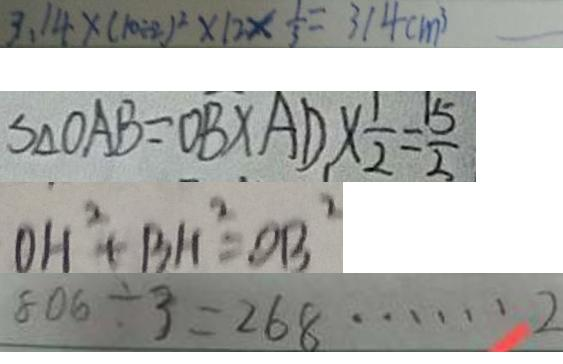Convert formula to latex. <formula><loc_0><loc_0><loc_500><loc_500>3 . 1 4 \times ( 1 0 \div 2 ) ^ { 2 } \times 1 2 \times \frac { 1 } { 3 } = 3 1 4 c m ^ { 3 } 
 S _ { \Delta O A B } = O B \times A D \times \frac { 1 } { 2 } = \frac { 1 5 } { 2 } 
 O H ^ { 2 } + B H ^ { 2 } = O B ^ { 2 } 
 8 0 6 \div 3 = 2 6 8 \cdots 2</formula> 